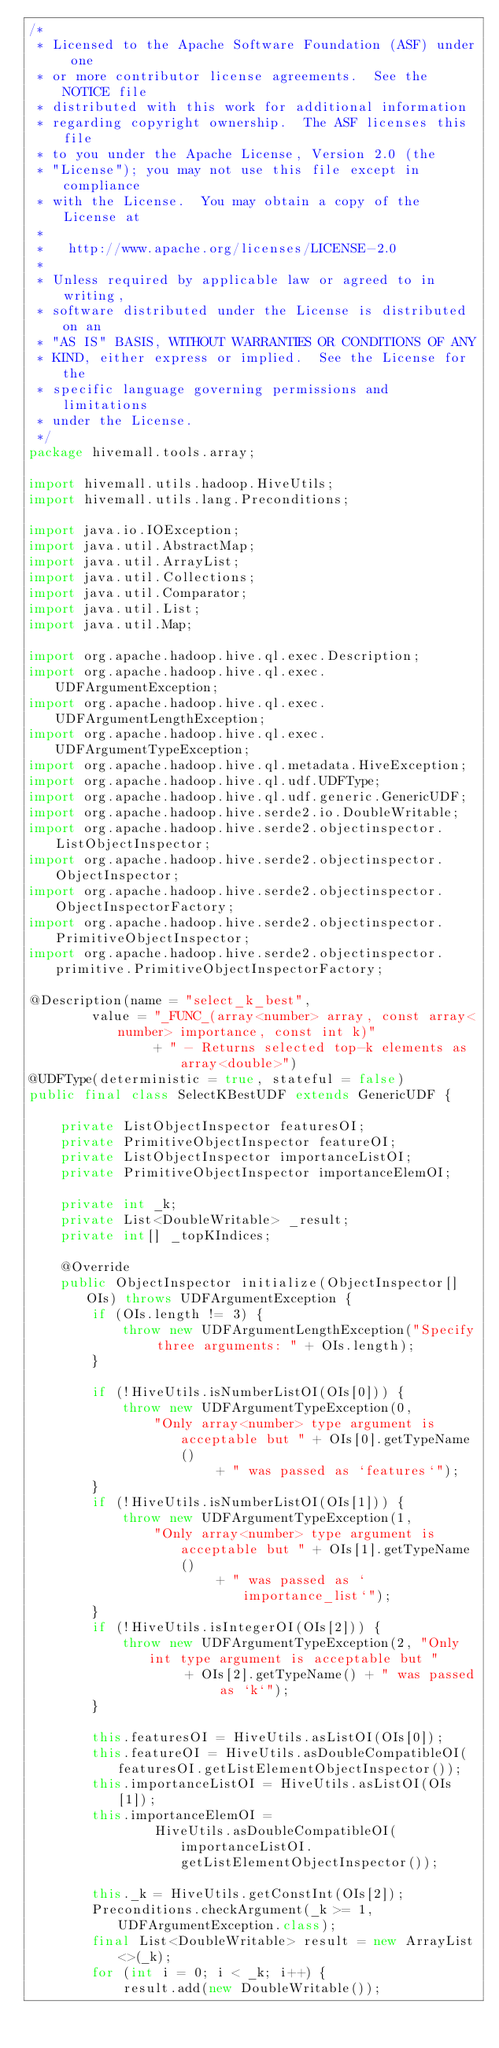<code> <loc_0><loc_0><loc_500><loc_500><_Java_>/*
 * Licensed to the Apache Software Foundation (ASF) under one
 * or more contributor license agreements.  See the NOTICE file
 * distributed with this work for additional information
 * regarding copyright ownership.  The ASF licenses this file
 * to you under the Apache License, Version 2.0 (the
 * "License"); you may not use this file except in compliance
 * with the License.  You may obtain a copy of the License at
 *
 *   http://www.apache.org/licenses/LICENSE-2.0
 *
 * Unless required by applicable law or agreed to in writing,
 * software distributed under the License is distributed on an
 * "AS IS" BASIS, WITHOUT WARRANTIES OR CONDITIONS OF ANY
 * KIND, either express or implied.  See the License for the
 * specific language governing permissions and limitations
 * under the License.
 */
package hivemall.tools.array;

import hivemall.utils.hadoop.HiveUtils;
import hivemall.utils.lang.Preconditions;

import java.io.IOException;
import java.util.AbstractMap;
import java.util.ArrayList;
import java.util.Collections;
import java.util.Comparator;
import java.util.List;
import java.util.Map;

import org.apache.hadoop.hive.ql.exec.Description;
import org.apache.hadoop.hive.ql.exec.UDFArgumentException;
import org.apache.hadoop.hive.ql.exec.UDFArgumentLengthException;
import org.apache.hadoop.hive.ql.exec.UDFArgumentTypeException;
import org.apache.hadoop.hive.ql.metadata.HiveException;
import org.apache.hadoop.hive.ql.udf.UDFType;
import org.apache.hadoop.hive.ql.udf.generic.GenericUDF;
import org.apache.hadoop.hive.serde2.io.DoubleWritable;
import org.apache.hadoop.hive.serde2.objectinspector.ListObjectInspector;
import org.apache.hadoop.hive.serde2.objectinspector.ObjectInspector;
import org.apache.hadoop.hive.serde2.objectinspector.ObjectInspectorFactory;
import org.apache.hadoop.hive.serde2.objectinspector.PrimitiveObjectInspector;
import org.apache.hadoop.hive.serde2.objectinspector.primitive.PrimitiveObjectInspectorFactory;

@Description(name = "select_k_best",
        value = "_FUNC_(array<number> array, const array<number> importance, const int k)"
                + " - Returns selected top-k elements as array<double>")
@UDFType(deterministic = true, stateful = false)
public final class SelectKBestUDF extends GenericUDF {

    private ListObjectInspector featuresOI;
    private PrimitiveObjectInspector featureOI;
    private ListObjectInspector importanceListOI;
    private PrimitiveObjectInspector importanceElemOI;

    private int _k;
    private List<DoubleWritable> _result;
    private int[] _topKIndices;

    @Override
    public ObjectInspector initialize(ObjectInspector[] OIs) throws UDFArgumentException {
        if (OIs.length != 3) {
            throw new UDFArgumentLengthException("Specify three arguments: " + OIs.length);
        }

        if (!HiveUtils.isNumberListOI(OIs[0])) {
            throw new UDFArgumentTypeException(0,
                "Only array<number> type argument is acceptable but " + OIs[0].getTypeName()
                        + " was passed as `features`");
        }
        if (!HiveUtils.isNumberListOI(OIs[1])) {
            throw new UDFArgumentTypeException(1,
                "Only array<number> type argument is acceptable but " + OIs[1].getTypeName()
                        + " was passed as `importance_list`");
        }
        if (!HiveUtils.isIntegerOI(OIs[2])) {
            throw new UDFArgumentTypeException(2, "Only int type argument is acceptable but "
                    + OIs[2].getTypeName() + " was passed as `k`");
        }

        this.featuresOI = HiveUtils.asListOI(OIs[0]);
        this.featureOI = HiveUtils.asDoubleCompatibleOI(featuresOI.getListElementObjectInspector());
        this.importanceListOI = HiveUtils.asListOI(OIs[1]);
        this.importanceElemOI =
                HiveUtils.asDoubleCompatibleOI(importanceListOI.getListElementObjectInspector());

        this._k = HiveUtils.getConstInt(OIs[2]);
        Preconditions.checkArgument(_k >= 1, UDFArgumentException.class);
        final List<DoubleWritable> result = new ArrayList<>(_k);
        for (int i = 0; i < _k; i++) {
            result.add(new DoubleWritable());</code> 